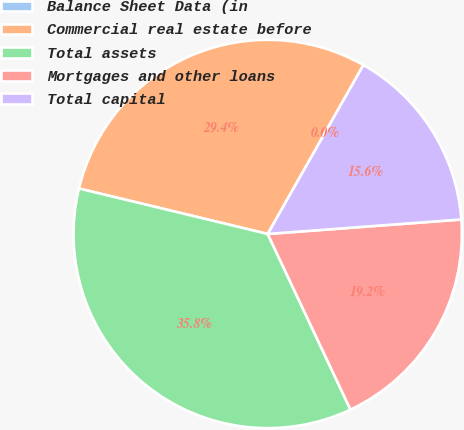Convert chart to OTSL. <chart><loc_0><loc_0><loc_500><loc_500><pie_chart><fcel>Balance Sheet Data (in<fcel>Commercial real estate before<fcel>Total assets<fcel>Mortgages and other loans<fcel>Total capital<nl><fcel>0.0%<fcel>29.44%<fcel>35.77%<fcel>19.18%<fcel>15.61%<nl></chart> 